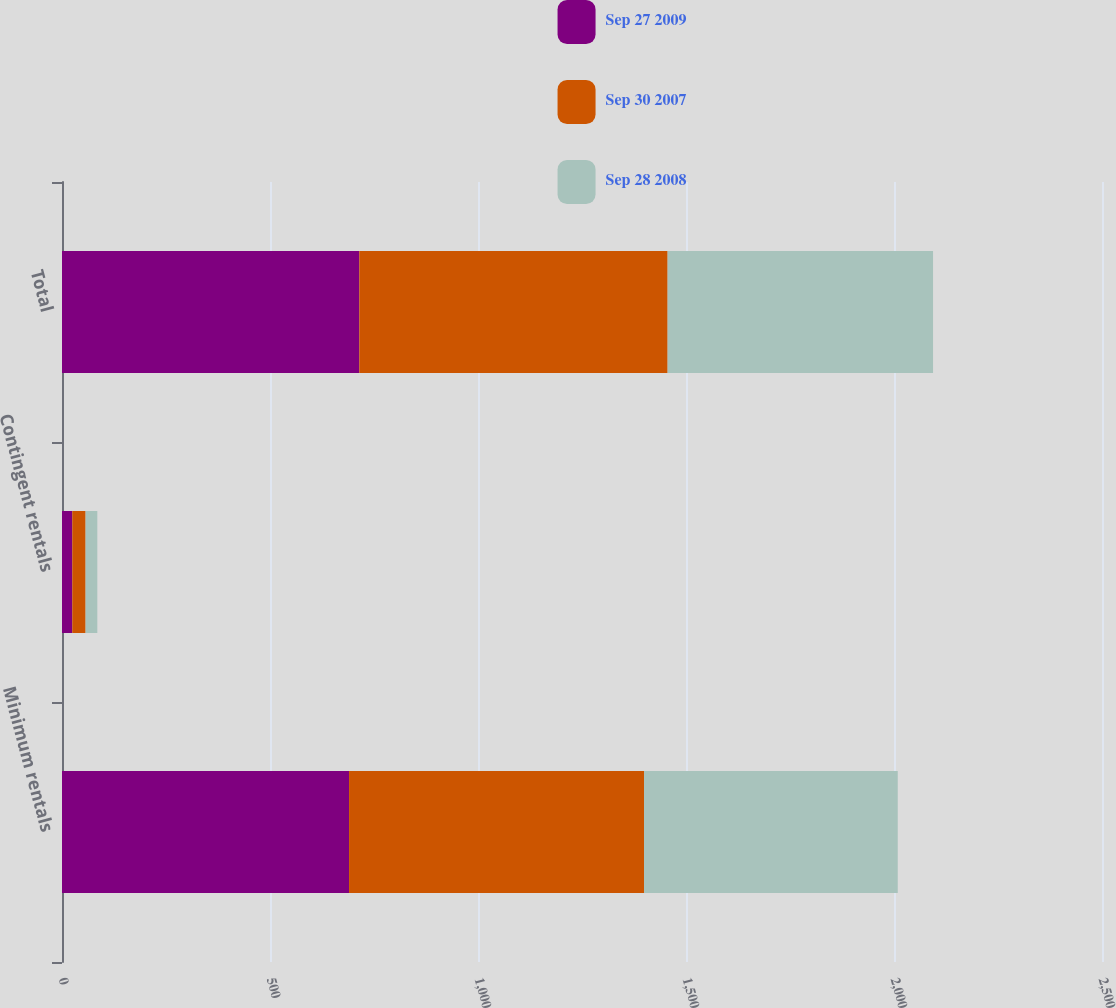<chart> <loc_0><loc_0><loc_500><loc_500><stacked_bar_chart><ecel><fcel>Minimum rentals<fcel>Contingent rentals<fcel>Total<nl><fcel>Sep 27 2009<fcel>690<fcel>24.7<fcel>714.7<nl><fcel>Sep 30 2007<fcel>709.1<fcel>32<fcel>741.1<nl><fcel>Sep 28 2008<fcel>609.9<fcel>28.2<fcel>638.1<nl></chart> 